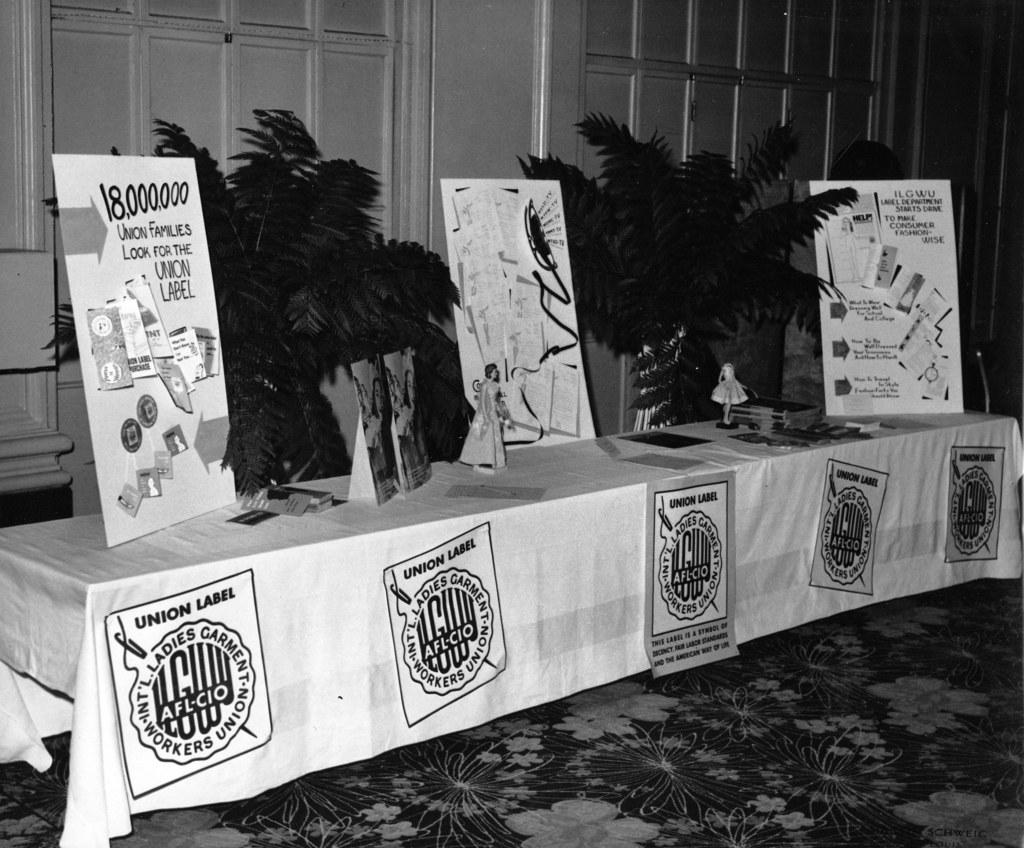<image>
Present a compact description of the photo's key features. An AFL-CIO table includes a sign about how many families look for the union label on products. 